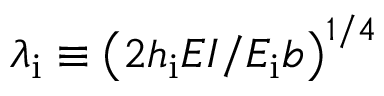Convert formula to latex. <formula><loc_0><loc_0><loc_500><loc_500>\lambda _ { i } \equiv \left ( { 2 h _ { i } E I } / { E _ { i } b } \right ) ^ { 1 / 4 }</formula> 